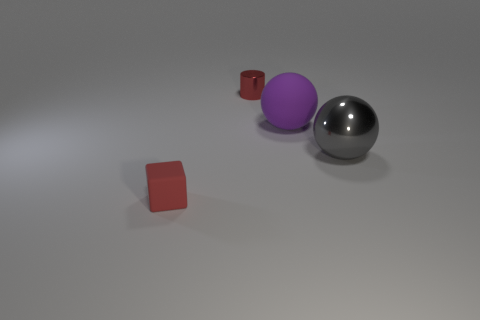What color is the large object that is to the right of the purple matte sphere? gray 